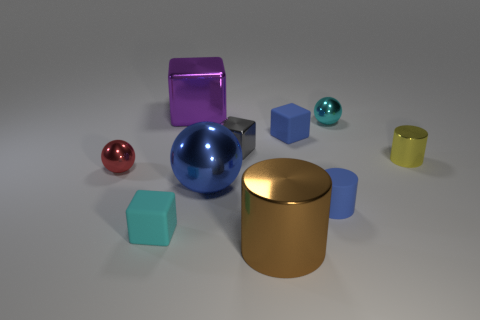There is a metallic cylinder to the right of the cyan object that is to the right of the big brown shiny object; what number of tiny rubber cubes are behind it?
Keep it short and to the point. 1. What number of small things are shiny spheres or cubes?
Provide a succinct answer. 5. Does the cyan thing that is to the right of the large blue object have the same material as the brown cylinder?
Provide a short and direct response. Yes. What material is the tiny object to the left of the matte cube that is in front of the blue object that is left of the large brown metallic cylinder?
Offer a terse response. Metal. Is there any other thing that has the same size as the cyan rubber thing?
Keep it short and to the point. Yes. How many rubber things are big blocks or large brown cylinders?
Provide a succinct answer. 0. Are any cyan blocks visible?
Offer a terse response. Yes. There is a small metallic ball left of the tiny metallic sphere behind the yellow cylinder; what is its color?
Ensure brevity in your answer.  Red. How many other objects are the same color as the large ball?
Offer a very short reply. 2. How many objects are small brown shiny things or metal cylinders that are right of the tiny blue rubber block?
Ensure brevity in your answer.  1. 